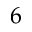Convert formula to latex. <formula><loc_0><loc_0><loc_500><loc_500>6</formula> 